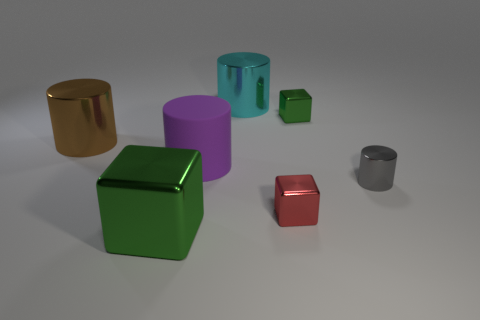What can you infer about the material properties of the objects based on their appearance? The objects' glossy surfaces and reflections suggest they are made of materials with a metallic finish. The way they reflect light indicates that they are likely smooth and hard. Their different colors might imply they are coated with various metallic paints or anodized treatments. 